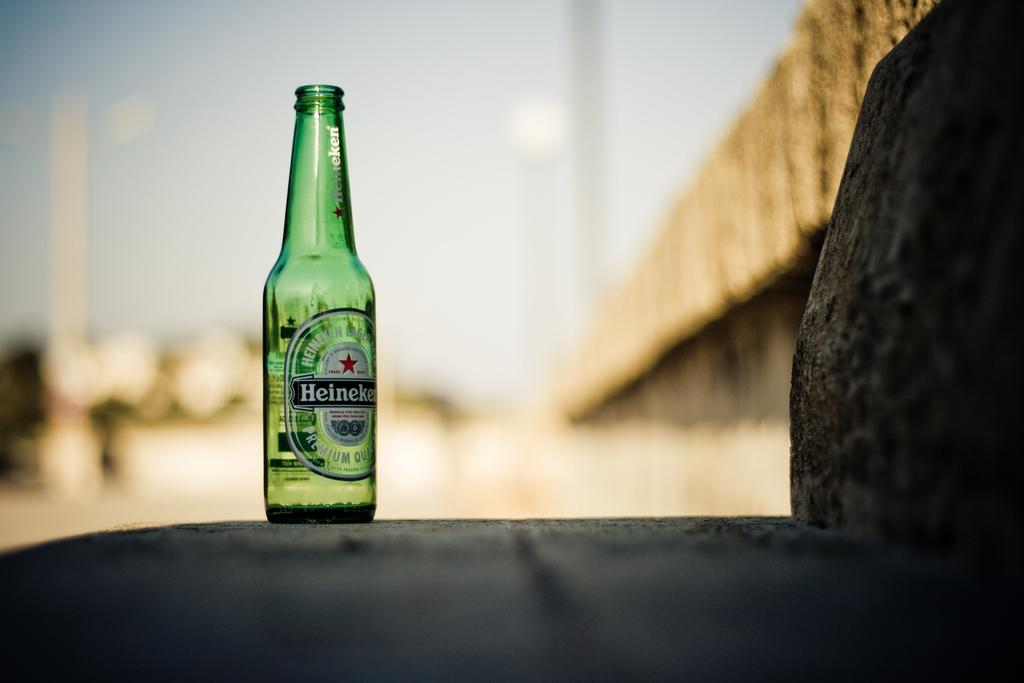<image>
Create a compact narrative representing the image presented. A bottle of heineken beer is shown against a blurry background. 